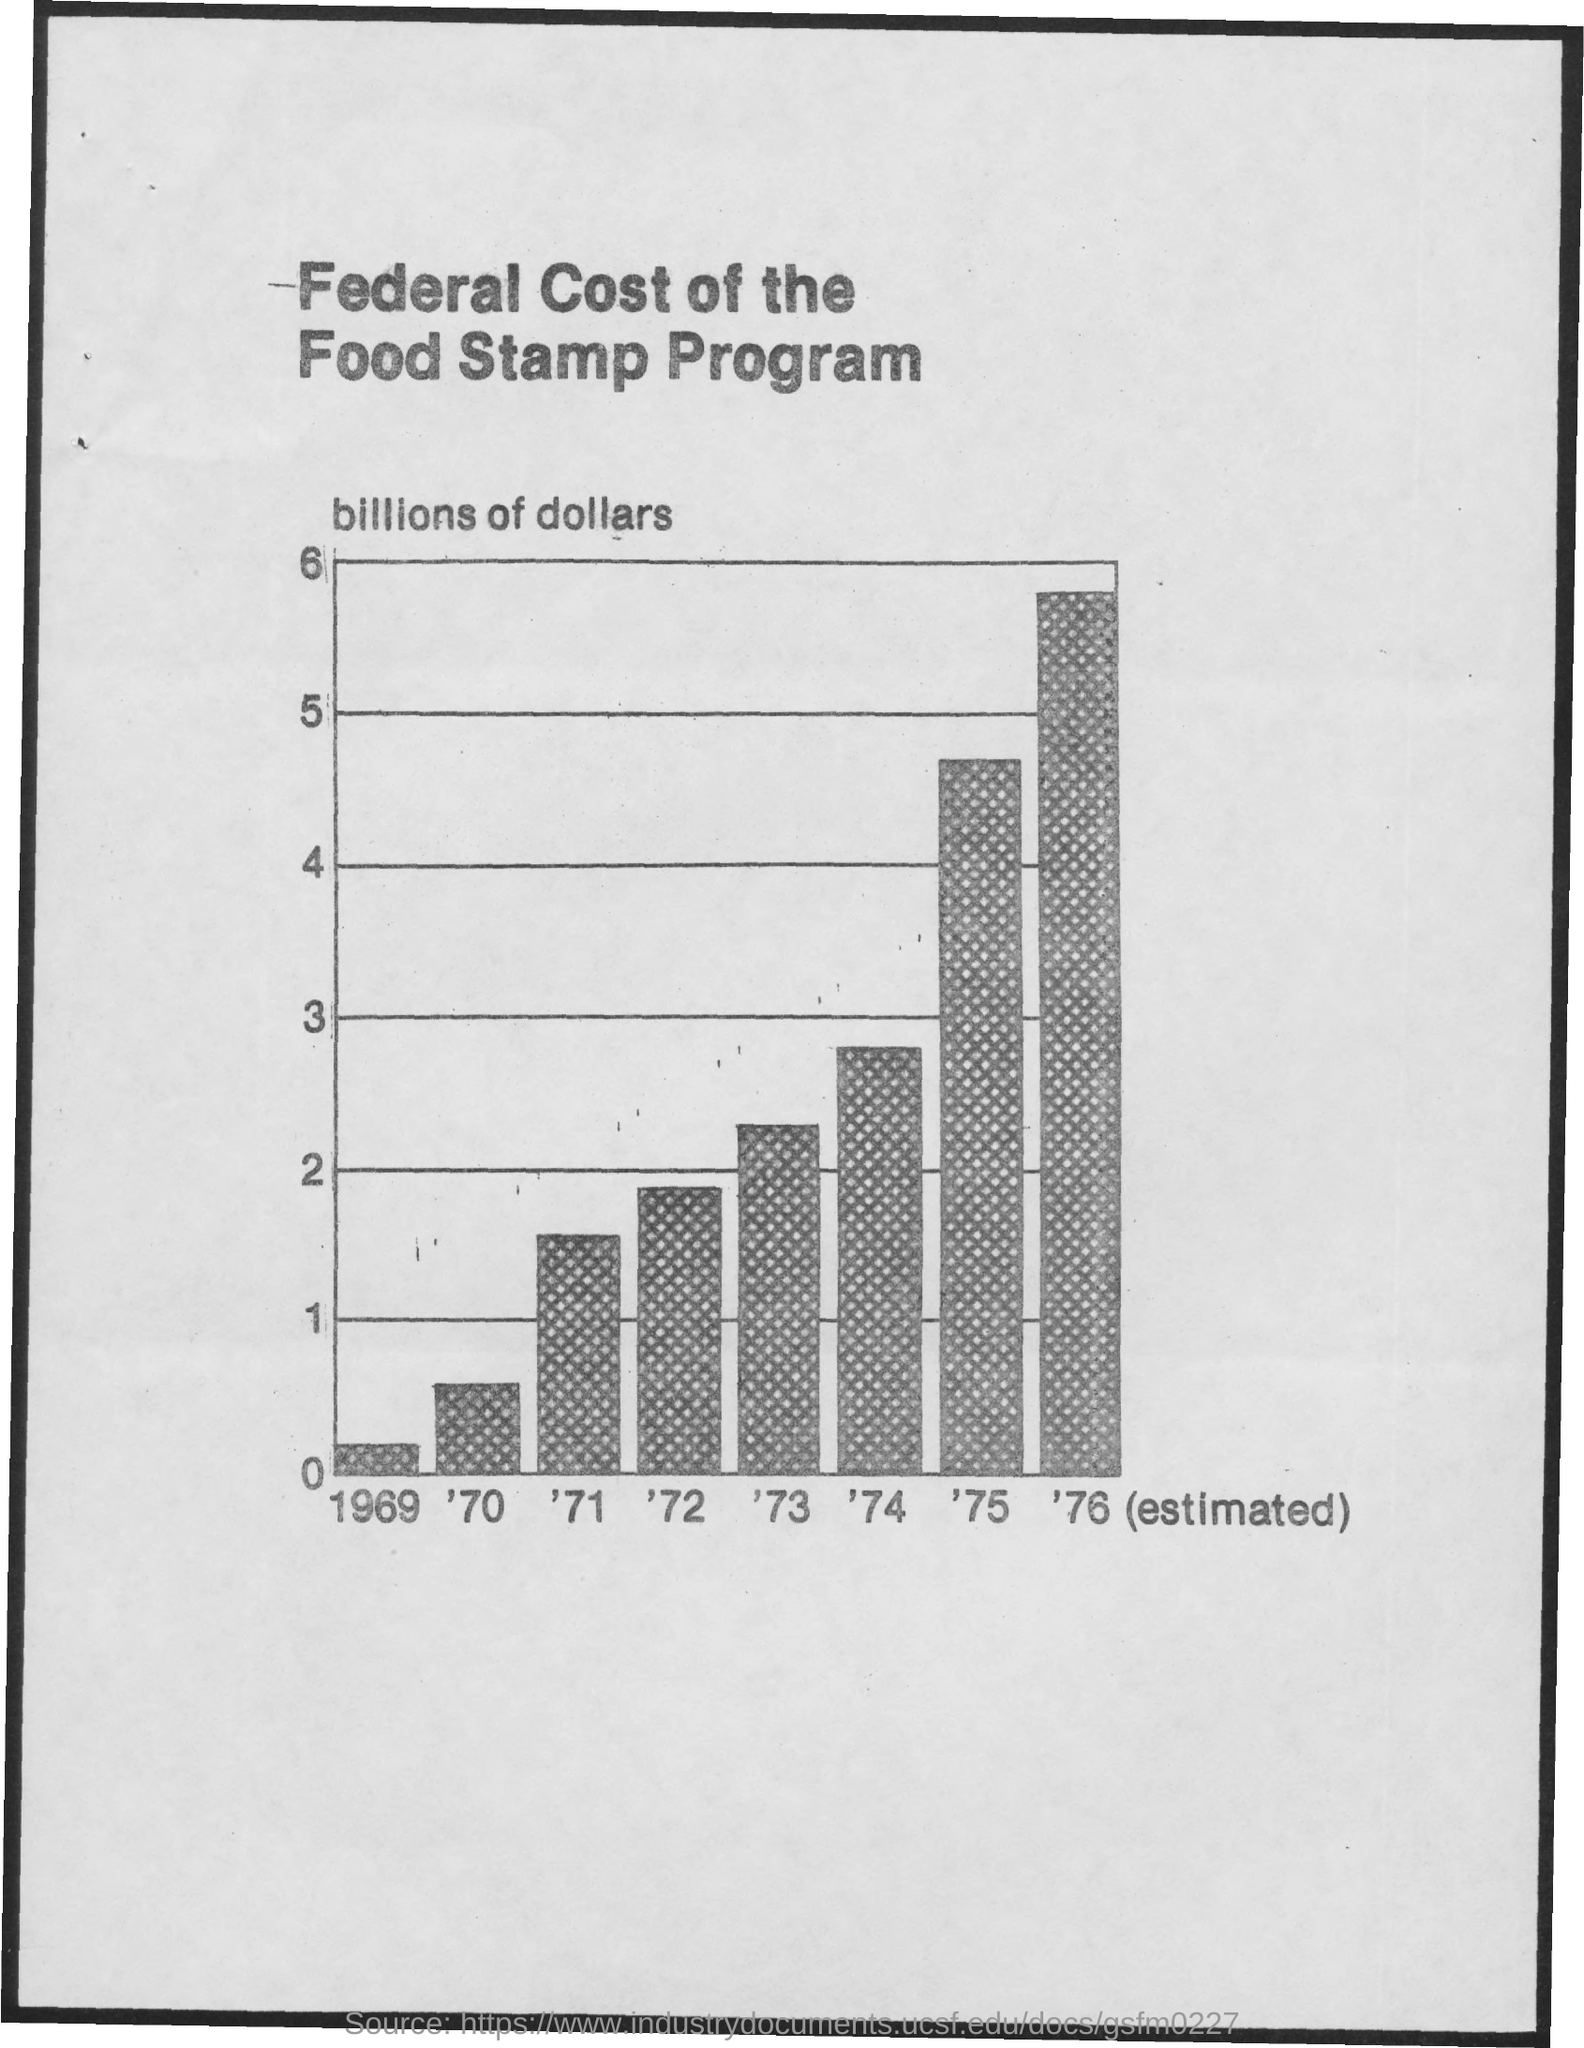What is the title of the document?
Give a very brief answer. Federal Cost of the Food Stamp Program. The second highest value is in which year?
Your answer should be compact. '75. The highest value is in which year?
Give a very brief answer. '76. The lowest value is in which year?
Ensure brevity in your answer.  1969. The second-lowest value is in which year?
Ensure brevity in your answer.  '70. The third highest value is in which year?
Keep it short and to the point. '74. 